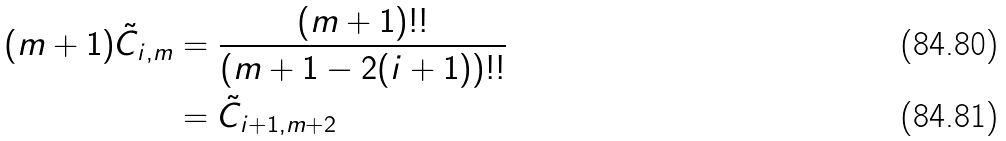<formula> <loc_0><loc_0><loc_500><loc_500>( m + 1 ) \tilde { C } _ { i , m } & = \frac { ( m + 1 ) ! ! } { ( m + 1 - 2 ( i + 1 ) ) ! ! } \\ & = \tilde { C } _ { i + 1 , m + 2 }</formula> 